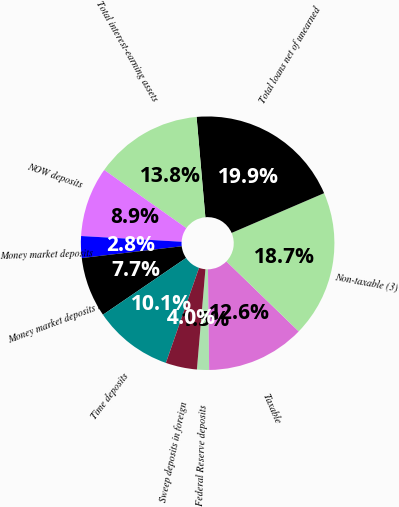<chart> <loc_0><loc_0><loc_500><loc_500><pie_chart><fcel>Federal Reserve deposits<fcel>Taxable<fcel>Non-taxable (3)<fcel>Total loans net of unearned<fcel>Total interest-earning assets<fcel>NOW deposits<fcel>Money market deposits<fcel>Money market deposits in<fcel>Time deposits<fcel>Sweep deposits in foreign<nl><fcel>1.54%<fcel>12.57%<fcel>18.7%<fcel>19.93%<fcel>13.8%<fcel>8.9%<fcel>2.77%<fcel>7.67%<fcel>10.12%<fcel>3.99%<nl></chart> 